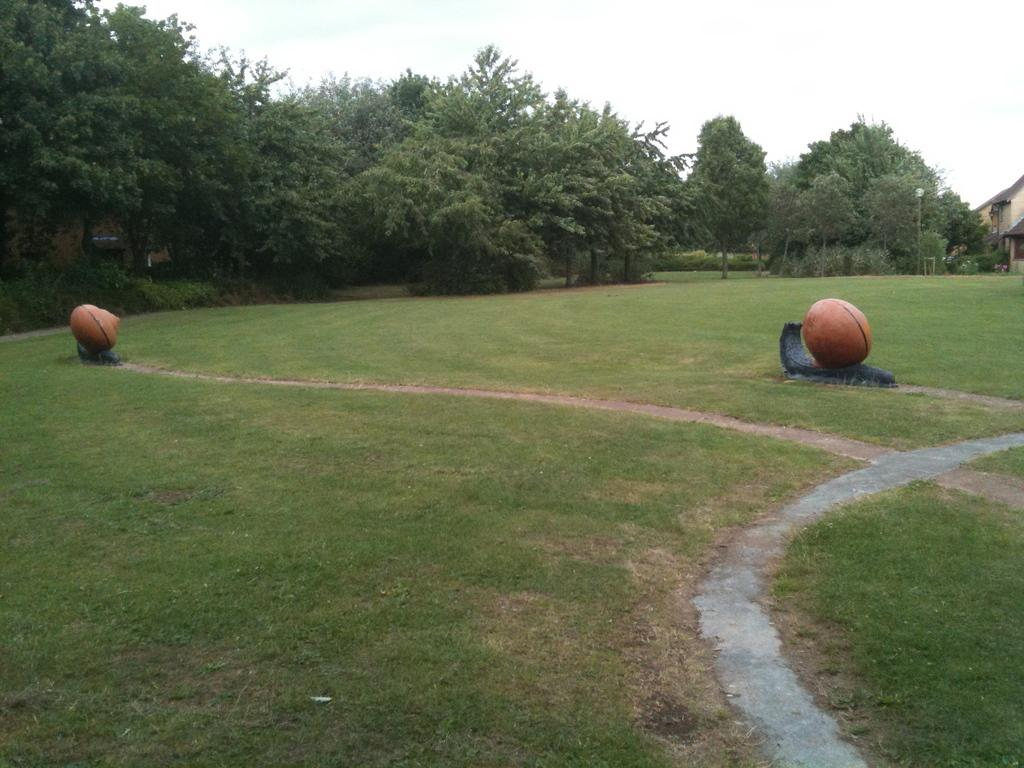What type of objects are on the grass in the image? There are ball-shaped objects on the grass. What can be seen in the background of the image? There are trees visible in the image. What type of structure is present in the image? There is a building in the image. What color is the vest worn by the temper in the image? There is no vest or temper present in the image. 